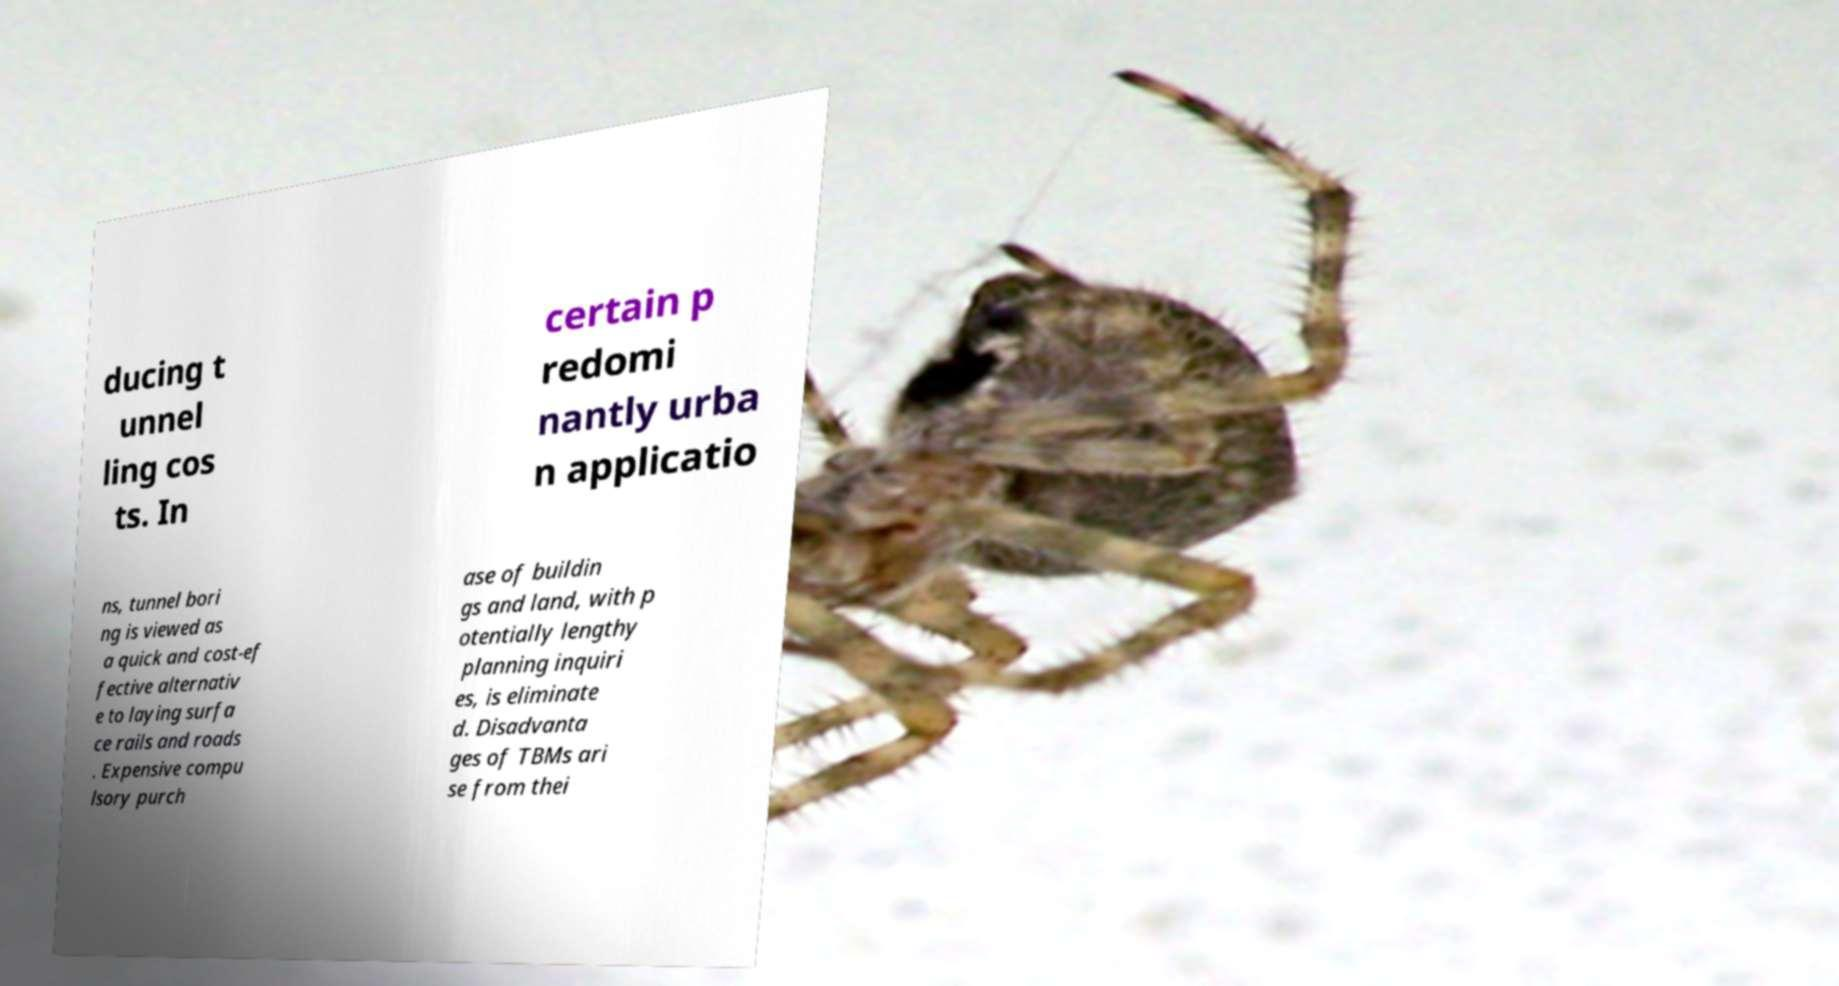Could you assist in decoding the text presented in this image and type it out clearly? ducing t unnel ling cos ts. In certain p redomi nantly urba n applicatio ns, tunnel bori ng is viewed as a quick and cost-ef fective alternativ e to laying surfa ce rails and roads . Expensive compu lsory purch ase of buildin gs and land, with p otentially lengthy planning inquiri es, is eliminate d. Disadvanta ges of TBMs ari se from thei 